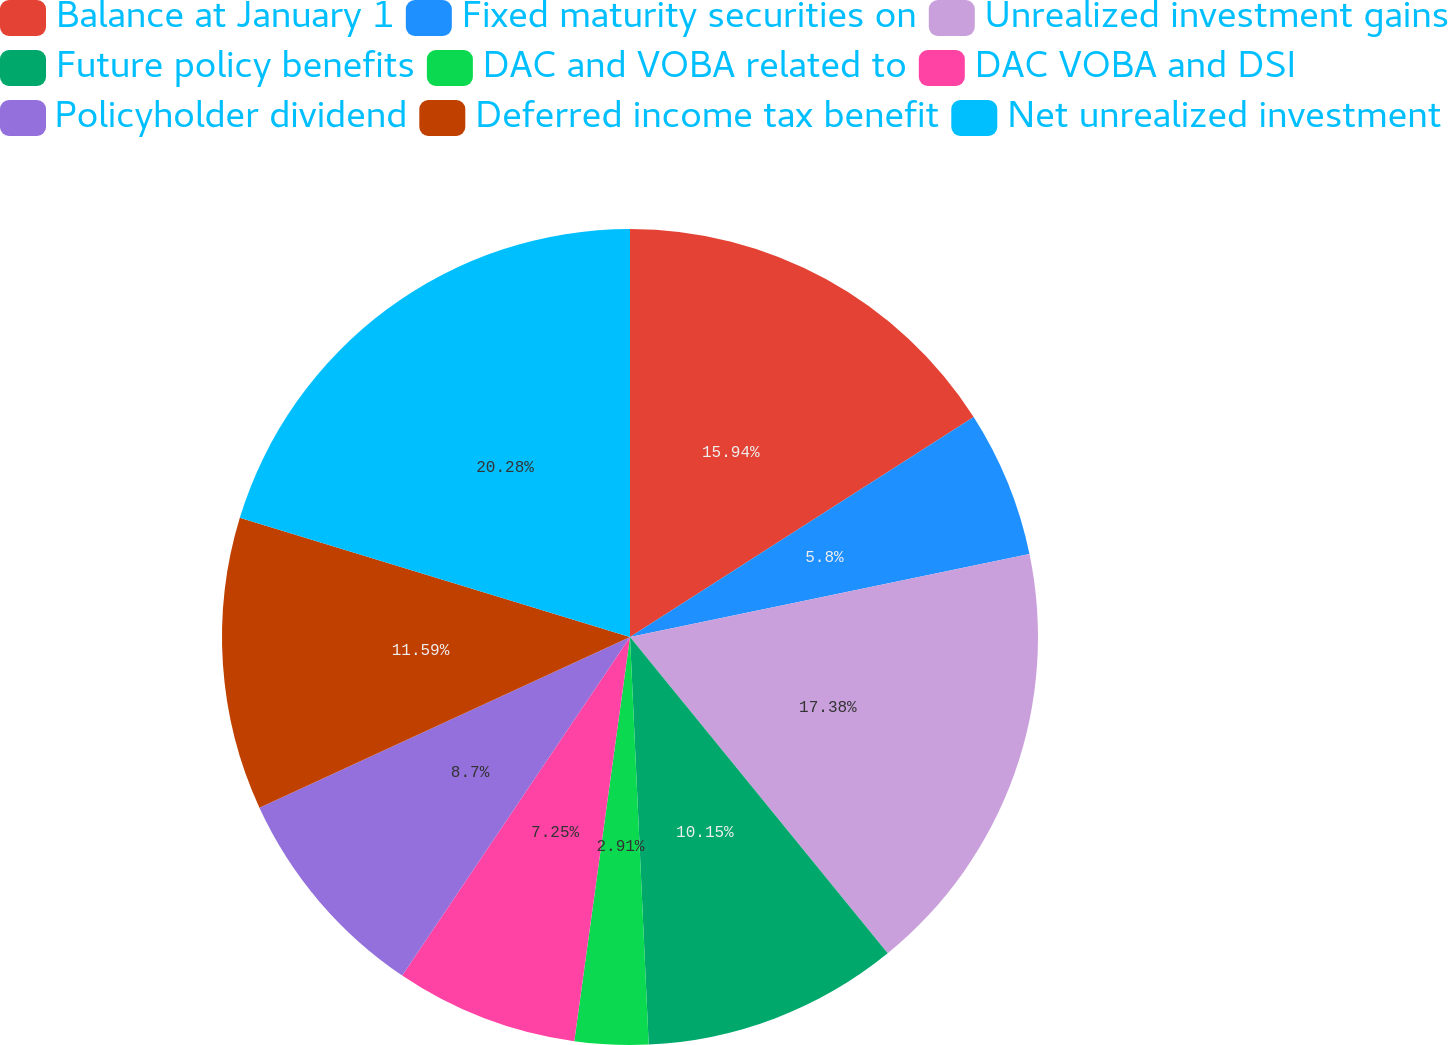<chart> <loc_0><loc_0><loc_500><loc_500><pie_chart><fcel>Balance at January 1<fcel>Fixed maturity securities on<fcel>Unrealized investment gains<fcel>Future policy benefits<fcel>DAC and VOBA related to<fcel>DAC VOBA and DSI<fcel>Policyholder dividend<fcel>Deferred income tax benefit<fcel>Net unrealized investment<nl><fcel>15.94%<fcel>5.8%<fcel>17.38%<fcel>10.15%<fcel>2.91%<fcel>7.25%<fcel>8.7%<fcel>11.59%<fcel>20.28%<nl></chart> 